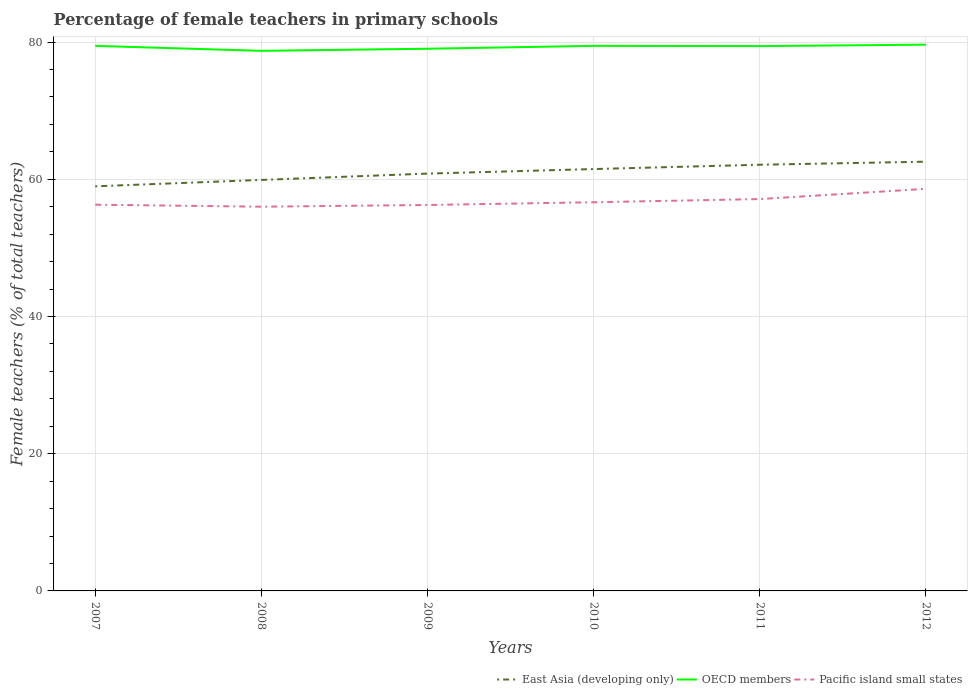Does the line corresponding to East Asia (developing only) intersect with the line corresponding to OECD members?
Offer a terse response. No. Across all years, what is the maximum percentage of female teachers in East Asia (developing only)?
Provide a short and direct response. 58.97. In which year was the percentage of female teachers in East Asia (developing only) maximum?
Provide a succinct answer. 2007. What is the total percentage of female teachers in OECD members in the graph?
Provide a succinct answer. -0.59. What is the difference between the highest and the second highest percentage of female teachers in East Asia (developing only)?
Ensure brevity in your answer.  3.59. How many lines are there?
Provide a succinct answer. 3. Does the graph contain grids?
Your response must be concise. Yes. Where does the legend appear in the graph?
Your answer should be compact. Bottom right. How are the legend labels stacked?
Keep it short and to the point. Horizontal. What is the title of the graph?
Provide a short and direct response. Percentage of female teachers in primary schools. What is the label or title of the Y-axis?
Provide a short and direct response. Female teachers (% of total teachers). What is the Female teachers (% of total teachers) of East Asia (developing only) in 2007?
Provide a succinct answer. 58.97. What is the Female teachers (% of total teachers) in OECD members in 2007?
Provide a succinct answer. 79.44. What is the Female teachers (% of total teachers) in Pacific island small states in 2007?
Make the answer very short. 56.29. What is the Female teachers (% of total teachers) of East Asia (developing only) in 2008?
Provide a short and direct response. 59.9. What is the Female teachers (% of total teachers) in OECD members in 2008?
Offer a terse response. 78.71. What is the Female teachers (% of total teachers) in Pacific island small states in 2008?
Your answer should be very brief. 56. What is the Female teachers (% of total teachers) of East Asia (developing only) in 2009?
Give a very brief answer. 60.82. What is the Female teachers (% of total teachers) of OECD members in 2009?
Your response must be concise. 79.02. What is the Female teachers (% of total teachers) of Pacific island small states in 2009?
Keep it short and to the point. 56.25. What is the Female teachers (% of total teachers) of East Asia (developing only) in 2010?
Give a very brief answer. 61.49. What is the Female teachers (% of total teachers) in OECD members in 2010?
Make the answer very short. 79.44. What is the Female teachers (% of total teachers) of Pacific island small states in 2010?
Your response must be concise. 56.65. What is the Female teachers (% of total teachers) in East Asia (developing only) in 2011?
Offer a very short reply. 62.11. What is the Female teachers (% of total teachers) in OECD members in 2011?
Keep it short and to the point. 79.4. What is the Female teachers (% of total teachers) of Pacific island small states in 2011?
Your response must be concise. 57.11. What is the Female teachers (% of total teachers) in East Asia (developing only) in 2012?
Your answer should be compact. 62.56. What is the Female teachers (% of total teachers) of OECD members in 2012?
Provide a succinct answer. 79.61. What is the Female teachers (% of total teachers) in Pacific island small states in 2012?
Give a very brief answer. 58.6. Across all years, what is the maximum Female teachers (% of total teachers) of East Asia (developing only)?
Provide a succinct answer. 62.56. Across all years, what is the maximum Female teachers (% of total teachers) of OECD members?
Keep it short and to the point. 79.61. Across all years, what is the maximum Female teachers (% of total teachers) in Pacific island small states?
Provide a short and direct response. 58.6. Across all years, what is the minimum Female teachers (% of total teachers) of East Asia (developing only)?
Provide a succinct answer. 58.97. Across all years, what is the minimum Female teachers (% of total teachers) of OECD members?
Offer a terse response. 78.71. Across all years, what is the minimum Female teachers (% of total teachers) of Pacific island small states?
Your answer should be compact. 56. What is the total Female teachers (% of total teachers) in East Asia (developing only) in the graph?
Your response must be concise. 365.85. What is the total Female teachers (% of total teachers) in OECD members in the graph?
Ensure brevity in your answer.  475.63. What is the total Female teachers (% of total teachers) in Pacific island small states in the graph?
Your answer should be compact. 340.9. What is the difference between the Female teachers (% of total teachers) in East Asia (developing only) in 2007 and that in 2008?
Your answer should be very brief. -0.93. What is the difference between the Female teachers (% of total teachers) in OECD members in 2007 and that in 2008?
Provide a short and direct response. 0.72. What is the difference between the Female teachers (% of total teachers) in Pacific island small states in 2007 and that in 2008?
Provide a short and direct response. 0.29. What is the difference between the Female teachers (% of total teachers) of East Asia (developing only) in 2007 and that in 2009?
Offer a very short reply. -1.85. What is the difference between the Female teachers (% of total teachers) of OECD members in 2007 and that in 2009?
Your answer should be compact. 0.42. What is the difference between the Female teachers (% of total teachers) in Pacific island small states in 2007 and that in 2009?
Your response must be concise. 0.04. What is the difference between the Female teachers (% of total teachers) of East Asia (developing only) in 2007 and that in 2010?
Keep it short and to the point. -2.52. What is the difference between the Female teachers (% of total teachers) in OECD members in 2007 and that in 2010?
Provide a short and direct response. -0. What is the difference between the Female teachers (% of total teachers) in Pacific island small states in 2007 and that in 2010?
Keep it short and to the point. -0.35. What is the difference between the Female teachers (% of total teachers) in East Asia (developing only) in 2007 and that in 2011?
Offer a terse response. -3.14. What is the difference between the Female teachers (% of total teachers) of OECD members in 2007 and that in 2011?
Your answer should be compact. 0.03. What is the difference between the Female teachers (% of total teachers) in Pacific island small states in 2007 and that in 2011?
Provide a short and direct response. -0.82. What is the difference between the Female teachers (% of total teachers) of East Asia (developing only) in 2007 and that in 2012?
Provide a succinct answer. -3.59. What is the difference between the Female teachers (% of total teachers) of OECD members in 2007 and that in 2012?
Your answer should be compact. -0.17. What is the difference between the Female teachers (% of total teachers) of Pacific island small states in 2007 and that in 2012?
Your answer should be compact. -2.31. What is the difference between the Female teachers (% of total teachers) of East Asia (developing only) in 2008 and that in 2009?
Give a very brief answer. -0.92. What is the difference between the Female teachers (% of total teachers) of OECD members in 2008 and that in 2009?
Your response must be concise. -0.31. What is the difference between the Female teachers (% of total teachers) of Pacific island small states in 2008 and that in 2009?
Your answer should be compact. -0.25. What is the difference between the Female teachers (% of total teachers) of East Asia (developing only) in 2008 and that in 2010?
Ensure brevity in your answer.  -1.58. What is the difference between the Female teachers (% of total teachers) in OECD members in 2008 and that in 2010?
Provide a succinct answer. -0.73. What is the difference between the Female teachers (% of total teachers) of Pacific island small states in 2008 and that in 2010?
Your answer should be very brief. -0.65. What is the difference between the Female teachers (% of total teachers) of East Asia (developing only) in 2008 and that in 2011?
Make the answer very short. -2.21. What is the difference between the Female teachers (% of total teachers) in OECD members in 2008 and that in 2011?
Offer a terse response. -0.69. What is the difference between the Female teachers (% of total teachers) of Pacific island small states in 2008 and that in 2011?
Your answer should be compact. -1.11. What is the difference between the Female teachers (% of total teachers) in East Asia (developing only) in 2008 and that in 2012?
Your answer should be compact. -2.66. What is the difference between the Female teachers (% of total teachers) of OECD members in 2008 and that in 2012?
Your answer should be very brief. -0.9. What is the difference between the Female teachers (% of total teachers) in Pacific island small states in 2008 and that in 2012?
Your answer should be compact. -2.6. What is the difference between the Female teachers (% of total teachers) in East Asia (developing only) in 2009 and that in 2010?
Make the answer very short. -0.66. What is the difference between the Female teachers (% of total teachers) in OECD members in 2009 and that in 2010?
Offer a terse response. -0.42. What is the difference between the Female teachers (% of total teachers) of Pacific island small states in 2009 and that in 2010?
Keep it short and to the point. -0.4. What is the difference between the Female teachers (% of total teachers) in East Asia (developing only) in 2009 and that in 2011?
Offer a very short reply. -1.29. What is the difference between the Female teachers (% of total teachers) in OECD members in 2009 and that in 2011?
Your answer should be very brief. -0.38. What is the difference between the Female teachers (% of total teachers) in Pacific island small states in 2009 and that in 2011?
Ensure brevity in your answer.  -0.86. What is the difference between the Female teachers (% of total teachers) of East Asia (developing only) in 2009 and that in 2012?
Offer a terse response. -1.74. What is the difference between the Female teachers (% of total teachers) in OECD members in 2009 and that in 2012?
Ensure brevity in your answer.  -0.59. What is the difference between the Female teachers (% of total teachers) in Pacific island small states in 2009 and that in 2012?
Give a very brief answer. -2.35. What is the difference between the Female teachers (% of total teachers) of East Asia (developing only) in 2010 and that in 2011?
Offer a terse response. -0.63. What is the difference between the Female teachers (% of total teachers) in OECD members in 2010 and that in 2011?
Your answer should be very brief. 0.03. What is the difference between the Female teachers (% of total teachers) of Pacific island small states in 2010 and that in 2011?
Offer a terse response. -0.47. What is the difference between the Female teachers (% of total teachers) of East Asia (developing only) in 2010 and that in 2012?
Provide a short and direct response. -1.07. What is the difference between the Female teachers (% of total teachers) of OECD members in 2010 and that in 2012?
Offer a very short reply. -0.17. What is the difference between the Female teachers (% of total teachers) of Pacific island small states in 2010 and that in 2012?
Provide a succinct answer. -1.95. What is the difference between the Female teachers (% of total teachers) in East Asia (developing only) in 2011 and that in 2012?
Offer a very short reply. -0.45. What is the difference between the Female teachers (% of total teachers) of OECD members in 2011 and that in 2012?
Make the answer very short. -0.21. What is the difference between the Female teachers (% of total teachers) in Pacific island small states in 2011 and that in 2012?
Keep it short and to the point. -1.49. What is the difference between the Female teachers (% of total teachers) in East Asia (developing only) in 2007 and the Female teachers (% of total teachers) in OECD members in 2008?
Provide a succinct answer. -19.74. What is the difference between the Female teachers (% of total teachers) in East Asia (developing only) in 2007 and the Female teachers (% of total teachers) in Pacific island small states in 2008?
Your answer should be very brief. 2.97. What is the difference between the Female teachers (% of total teachers) of OECD members in 2007 and the Female teachers (% of total teachers) of Pacific island small states in 2008?
Offer a terse response. 23.44. What is the difference between the Female teachers (% of total teachers) of East Asia (developing only) in 2007 and the Female teachers (% of total teachers) of OECD members in 2009?
Offer a terse response. -20.05. What is the difference between the Female teachers (% of total teachers) in East Asia (developing only) in 2007 and the Female teachers (% of total teachers) in Pacific island small states in 2009?
Give a very brief answer. 2.72. What is the difference between the Female teachers (% of total teachers) of OECD members in 2007 and the Female teachers (% of total teachers) of Pacific island small states in 2009?
Make the answer very short. 23.19. What is the difference between the Female teachers (% of total teachers) of East Asia (developing only) in 2007 and the Female teachers (% of total teachers) of OECD members in 2010?
Give a very brief answer. -20.47. What is the difference between the Female teachers (% of total teachers) of East Asia (developing only) in 2007 and the Female teachers (% of total teachers) of Pacific island small states in 2010?
Offer a very short reply. 2.32. What is the difference between the Female teachers (% of total teachers) of OECD members in 2007 and the Female teachers (% of total teachers) of Pacific island small states in 2010?
Keep it short and to the point. 22.79. What is the difference between the Female teachers (% of total teachers) of East Asia (developing only) in 2007 and the Female teachers (% of total teachers) of OECD members in 2011?
Keep it short and to the point. -20.44. What is the difference between the Female teachers (% of total teachers) of East Asia (developing only) in 2007 and the Female teachers (% of total teachers) of Pacific island small states in 2011?
Provide a short and direct response. 1.86. What is the difference between the Female teachers (% of total teachers) in OECD members in 2007 and the Female teachers (% of total teachers) in Pacific island small states in 2011?
Offer a very short reply. 22.33. What is the difference between the Female teachers (% of total teachers) of East Asia (developing only) in 2007 and the Female teachers (% of total teachers) of OECD members in 2012?
Make the answer very short. -20.64. What is the difference between the Female teachers (% of total teachers) of East Asia (developing only) in 2007 and the Female teachers (% of total teachers) of Pacific island small states in 2012?
Provide a succinct answer. 0.37. What is the difference between the Female teachers (% of total teachers) in OECD members in 2007 and the Female teachers (% of total teachers) in Pacific island small states in 2012?
Provide a succinct answer. 20.84. What is the difference between the Female teachers (% of total teachers) in East Asia (developing only) in 2008 and the Female teachers (% of total teachers) in OECD members in 2009?
Make the answer very short. -19.12. What is the difference between the Female teachers (% of total teachers) in East Asia (developing only) in 2008 and the Female teachers (% of total teachers) in Pacific island small states in 2009?
Offer a terse response. 3.65. What is the difference between the Female teachers (% of total teachers) in OECD members in 2008 and the Female teachers (% of total teachers) in Pacific island small states in 2009?
Ensure brevity in your answer.  22.46. What is the difference between the Female teachers (% of total teachers) of East Asia (developing only) in 2008 and the Female teachers (% of total teachers) of OECD members in 2010?
Your answer should be very brief. -19.54. What is the difference between the Female teachers (% of total teachers) of East Asia (developing only) in 2008 and the Female teachers (% of total teachers) of Pacific island small states in 2010?
Your answer should be very brief. 3.26. What is the difference between the Female teachers (% of total teachers) in OECD members in 2008 and the Female teachers (% of total teachers) in Pacific island small states in 2010?
Ensure brevity in your answer.  22.07. What is the difference between the Female teachers (% of total teachers) in East Asia (developing only) in 2008 and the Female teachers (% of total teachers) in OECD members in 2011?
Make the answer very short. -19.5. What is the difference between the Female teachers (% of total teachers) of East Asia (developing only) in 2008 and the Female teachers (% of total teachers) of Pacific island small states in 2011?
Ensure brevity in your answer.  2.79. What is the difference between the Female teachers (% of total teachers) in OECD members in 2008 and the Female teachers (% of total teachers) in Pacific island small states in 2011?
Offer a very short reply. 21.6. What is the difference between the Female teachers (% of total teachers) of East Asia (developing only) in 2008 and the Female teachers (% of total teachers) of OECD members in 2012?
Your answer should be very brief. -19.71. What is the difference between the Female teachers (% of total teachers) of East Asia (developing only) in 2008 and the Female teachers (% of total teachers) of Pacific island small states in 2012?
Offer a terse response. 1.3. What is the difference between the Female teachers (% of total teachers) in OECD members in 2008 and the Female teachers (% of total teachers) in Pacific island small states in 2012?
Provide a short and direct response. 20.11. What is the difference between the Female teachers (% of total teachers) of East Asia (developing only) in 2009 and the Female teachers (% of total teachers) of OECD members in 2010?
Provide a succinct answer. -18.62. What is the difference between the Female teachers (% of total teachers) of East Asia (developing only) in 2009 and the Female teachers (% of total teachers) of Pacific island small states in 2010?
Offer a very short reply. 4.18. What is the difference between the Female teachers (% of total teachers) in OECD members in 2009 and the Female teachers (% of total teachers) in Pacific island small states in 2010?
Ensure brevity in your answer.  22.37. What is the difference between the Female teachers (% of total teachers) of East Asia (developing only) in 2009 and the Female teachers (% of total teachers) of OECD members in 2011?
Make the answer very short. -18.58. What is the difference between the Female teachers (% of total teachers) of East Asia (developing only) in 2009 and the Female teachers (% of total teachers) of Pacific island small states in 2011?
Offer a very short reply. 3.71. What is the difference between the Female teachers (% of total teachers) in OECD members in 2009 and the Female teachers (% of total teachers) in Pacific island small states in 2011?
Offer a very short reply. 21.91. What is the difference between the Female teachers (% of total teachers) in East Asia (developing only) in 2009 and the Female teachers (% of total teachers) in OECD members in 2012?
Keep it short and to the point. -18.79. What is the difference between the Female teachers (% of total teachers) in East Asia (developing only) in 2009 and the Female teachers (% of total teachers) in Pacific island small states in 2012?
Your response must be concise. 2.22. What is the difference between the Female teachers (% of total teachers) in OECD members in 2009 and the Female teachers (% of total teachers) in Pacific island small states in 2012?
Keep it short and to the point. 20.42. What is the difference between the Female teachers (% of total teachers) of East Asia (developing only) in 2010 and the Female teachers (% of total teachers) of OECD members in 2011?
Ensure brevity in your answer.  -17.92. What is the difference between the Female teachers (% of total teachers) in East Asia (developing only) in 2010 and the Female teachers (% of total teachers) in Pacific island small states in 2011?
Provide a short and direct response. 4.37. What is the difference between the Female teachers (% of total teachers) of OECD members in 2010 and the Female teachers (% of total teachers) of Pacific island small states in 2011?
Ensure brevity in your answer.  22.33. What is the difference between the Female teachers (% of total teachers) in East Asia (developing only) in 2010 and the Female teachers (% of total teachers) in OECD members in 2012?
Provide a short and direct response. -18.13. What is the difference between the Female teachers (% of total teachers) in East Asia (developing only) in 2010 and the Female teachers (% of total teachers) in Pacific island small states in 2012?
Make the answer very short. 2.89. What is the difference between the Female teachers (% of total teachers) in OECD members in 2010 and the Female teachers (% of total teachers) in Pacific island small states in 2012?
Your answer should be compact. 20.84. What is the difference between the Female teachers (% of total teachers) of East Asia (developing only) in 2011 and the Female teachers (% of total teachers) of OECD members in 2012?
Ensure brevity in your answer.  -17.5. What is the difference between the Female teachers (% of total teachers) in East Asia (developing only) in 2011 and the Female teachers (% of total teachers) in Pacific island small states in 2012?
Provide a short and direct response. 3.51. What is the difference between the Female teachers (% of total teachers) of OECD members in 2011 and the Female teachers (% of total teachers) of Pacific island small states in 2012?
Keep it short and to the point. 20.8. What is the average Female teachers (% of total teachers) of East Asia (developing only) per year?
Keep it short and to the point. 60.98. What is the average Female teachers (% of total teachers) in OECD members per year?
Ensure brevity in your answer.  79.27. What is the average Female teachers (% of total teachers) of Pacific island small states per year?
Offer a very short reply. 56.82. In the year 2007, what is the difference between the Female teachers (% of total teachers) in East Asia (developing only) and Female teachers (% of total teachers) in OECD members?
Offer a very short reply. -20.47. In the year 2007, what is the difference between the Female teachers (% of total teachers) in East Asia (developing only) and Female teachers (% of total teachers) in Pacific island small states?
Provide a short and direct response. 2.68. In the year 2007, what is the difference between the Female teachers (% of total teachers) in OECD members and Female teachers (% of total teachers) in Pacific island small states?
Your answer should be compact. 23.14. In the year 2008, what is the difference between the Female teachers (% of total teachers) of East Asia (developing only) and Female teachers (% of total teachers) of OECD members?
Your response must be concise. -18.81. In the year 2008, what is the difference between the Female teachers (% of total teachers) in East Asia (developing only) and Female teachers (% of total teachers) in Pacific island small states?
Offer a very short reply. 3.9. In the year 2008, what is the difference between the Female teachers (% of total teachers) of OECD members and Female teachers (% of total teachers) of Pacific island small states?
Provide a succinct answer. 22.71. In the year 2009, what is the difference between the Female teachers (% of total teachers) in East Asia (developing only) and Female teachers (% of total teachers) in OECD members?
Your response must be concise. -18.2. In the year 2009, what is the difference between the Female teachers (% of total teachers) of East Asia (developing only) and Female teachers (% of total teachers) of Pacific island small states?
Make the answer very short. 4.57. In the year 2009, what is the difference between the Female teachers (% of total teachers) in OECD members and Female teachers (% of total teachers) in Pacific island small states?
Keep it short and to the point. 22.77. In the year 2010, what is the difference between the Female teachers (% of total teachers) in East Asia (developing only) and Female teachers (% of total teachers) in OECD members?
Offer a very short reply. -17.95. In the year 2010, what is the difference between the Female teachers (% of total teachers) of East Asia (developing only) and Female teachers (% of total teachers) of Pacific island small states?
Offer a terse response. 4.84. In the year 2010, what is the difference between the Female teachers (% of total teachers) of OECD members and Female teachers (% of total teachers) of Pacific island small states?
Keep it short and to the point. 22.79. In the year 2011, what is the difference between the Female teachers (% of total teachers) of East Asia (developing only) and Female teachers (% of total teachers) of OECD members?
Offer a very short reply. -17.29. In the year 2011, what is the difference between the Female teachers (% of total teachers) in East Asia (developing only) and Female teachers (% of total teachers) in Pacific island small states?
Give a very brief answer. 5. In the year 2011, what is the difference between the Female teachers (% of total teachers) in OECD members and Female teachers (% of total teachers) in Pacific island small states?
Your response must be concise. 22.29. In the year 2012, what is the difference between the Female teachers (% of total teachers) of East Asia (developing only) and Female teachers (% of total teachers) of OECD members?
Make the answer very short. -17.05. In the year 2012, what is the difference between the Female teachers (% of total teachers) in East Asia (developing only) and Female teachers (% of total teachers) in Pacific island small states?
Keep it short and to the point. 3.96. In the year 2012, what is the difference between the Female teachers (% of total teachers) of OECD members and Female teachers (% of total teachers) of Pacific island small states?
Make the answer very short. 21.01. What is the ratio of the Female teachers (% of total teachers) of East Asia (developing only) in 2007 to that in 2008?
Make the answer very short. 0.98. What is the ratio of the Female teachers (% of total teachers) of OECD members in 2007 to that in 2008?
Make the answer very short. 1.01. What is the ratio of the Female teachers (% of total teachers) in Pacific island small states in 2007 to that in 2008?
Your response must be concise. 1.01. What is the ratio of the Female teachers (% of total teachers) in East Asia (developing only) in 2007 to that in 2009?
Offer a terse response. 0.97. What is the ratio of the Female teachers (% of total teachers) of OECD members in 2007 to that in 2009?
Provide a succinct answer. 1.01. What is the ratio of the Female teachers (% of total teachers) in Pacific island small states in 2007 to that in 2009?
Offer a very short reply. 1. What is the ratio of the Female teachers (% of total teachers) of East Asia (developing only) in 2007 to that in 2010?
Provide a short and direct response. 0.96. What is the ratio of the Female teachers (% of total teachers) in Pacific island small states in 2007 to that in 2010?
Offer a terse response. 0.99. What is the ratio of the Female teachers (% of total teachers) in East Asia (developing only) in 2007 to that in 2011?
Make the answer very short. 0.95. What is the ratio of the Female teachers (% of total teachers) of Pacific island small states in 2007 to that in 2011?
Make the answer very short. 0.99. What is the ratio of the Female teachers (% of total teachers) in East Asia (developing only) in 2007 to that in 2012?
Keep it short and to the point. 0.94. What is the ratio of the Female teachers (% of total teachers) in Pacific island small states in 2007 to that in 2012?
Your answer should be very brief. 0.96. What is the ratio of the Female teachers (% of total teachers) in OECD members in 2008 to that in 2009?
Your answer should be compact. 1. What is the ratio of the Female teachers (% of total teachers) in East Asia (developing only) in 2008 to that in 2010?
Your answer should be very brief. 0.97. What is the ratio of the Female teachers (% of total teachers) of OECD members in 2008 to that in 2010?
Ensure brevity in your answer.  0.99. What is the ratio of the Female teachers (% of total teachers) in East Asia (developing only) in 2008 to that in 2011?
Offer a very short reply. 0.96. What is the ratio of the Female teachers (% of total teachers) of Pacific island small states in 2008 to that in 2011?
Your response must be concise. 0.98. What is the ratio of the Female teachers (% of total teachers) in East Asia (developing only) in 2008 to that in 2012?
Your answer should be very brief. 0.96. What is the ratio of the Female teachers (% of total teachers) of OECD members in 2008 to that in 2012?
Your response must be concise. 0.99. What is the ratio of the Female teachers (% of total teachers) in Pacific island small states in 2008 to that in 2012?
Ensure brevity in your answer.  0.96. What is the ratio of the Female teachers (% of total teachers) in East Asia (developing only) in 2009 to that in 2010?
Make the answer very short. 0.99. What is the ratio of the Female teachers (% of total teachers) of OECD members in 2009 to that in 2010?
Your answer should be very brief. 0.99. What is the ratio of the Female teachers (% of total teachers) of Pacific island small states in 2009 to that in 2010?
Offer a very short reply. 0.99. What is the ratio of the Female teachers (% of total teachers) of East Asia (developing only) in 2009 to that in 2011?
Offer a very short reply. 0.98. What is the ratio of the Female teachers (% of total teachers) of OECD members in 2009 to that in 2011?
Make the answer very short. 1. What is the ratio of the Female teachers (% of total teachers) in Pacific island small states in 2009 to that in 2011?
Keep it short and to the point. 0.98. What is the ratio of the Female teachers (% of total teachers) of East Asia (developing only) in 2009 to that in 2012?
Give a very brief answer. 0.97. What is the ratio of the Female teachers (% of total teachers) of OECD members in 2009 to that in 2012?
Offer a very short reply. 0.99. What is the ratio of the Female teachers (% of total teachers) in Pacific island small states in 2009 to that in 2012?
Make the answer very short. 0.96. What is the ratio of the Female teachers (% of total teachers) of OECD members in 2010 to that in 2011?
Provide a succinct answer. 1. What is the ratio of the Female teachers (% of total teachers) in East Asia (developing only) in 2010 to that in 2012?
Provide a succinct answer. 0.98. What is the ratio of the Female teachers (% of total teachers) in Pacific island small states in 2010 to that in 2012?
Your answer should be very brief. 0.97. What is the ratio of the Female teachers (% of total teachers) in East Asia (developing only) in 2011 to that in 2012?
Give a very brief answer. 0.99. What is the ratio of the Female teachers (% of total teachers) of Pacific island small states in 2011 to that in 2012?
Make the answer very short. 0.97. What is the difference between the highest and the second highest Female teachers (% of total teachers) in East Asia (developing only)?
Your response must be concise. 0.45. What is the difference between the highest and the second highest Female teachers (% of total teachers) of OECD members?
Your answer should be very brief. 0.17. What is the difference between the highest and the second highest Female teachers (% of total teachers) in Pacific island small states?
Your response must be concise. 1.49. What is the difference between the highest and the lowest Female teachers (% of total teachers) of East Asia (developing only)?
Your response must be concise. 3.59. What is the difference between the highest and the lowest Female teachers (% of total teachers) of OECD members?
Make the answer very short. 0.9. What is the difference between the highest and the lowest Female teachers (% of total teachers) of Pacific island small states?
Offer a very short reply. 2.6. 